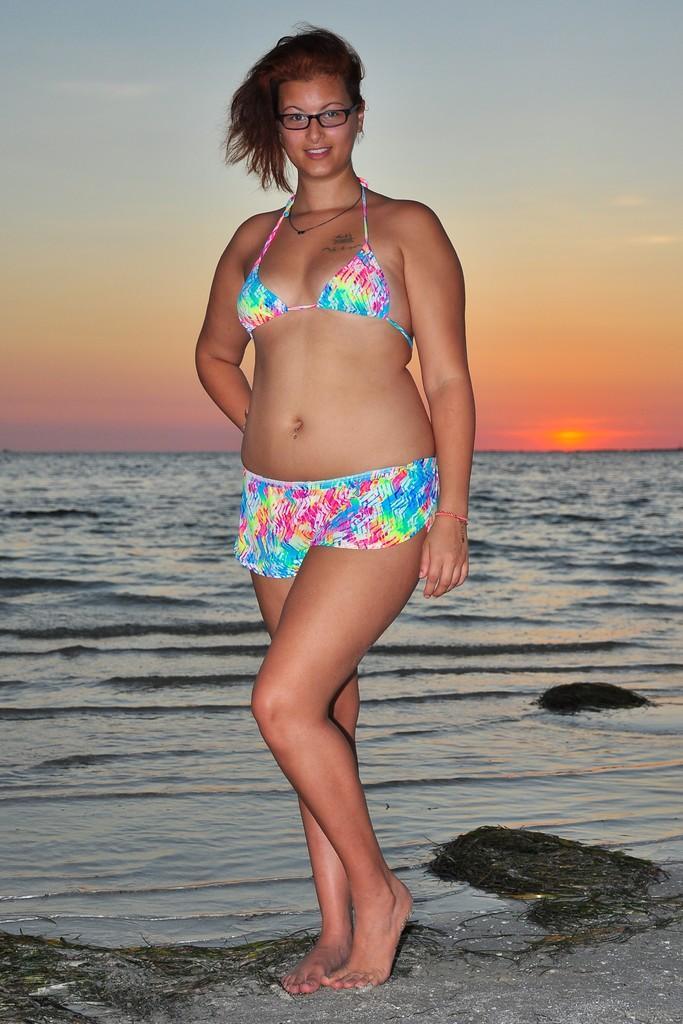Can you describe this image briefly? In this image we can see woman standing at the sea. In the background there is a water and sky. 